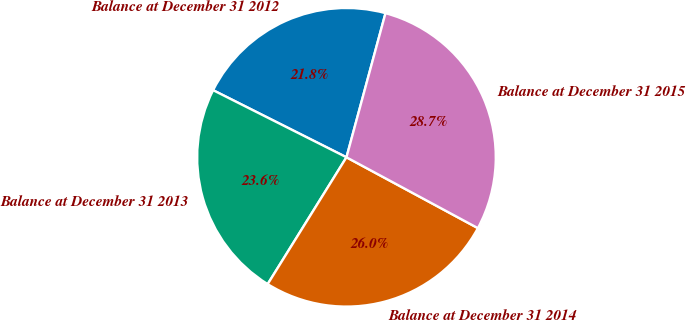Convert chart to OTSL. <chart><loc_0><loc_0><loc_500><loc_500><pie_chart><fcel>Balance at December 31 2012<fcel>Balance at December 31 2013<fcel>Balance at December 31 2014<fcel>Balance at December 31 2015<nl><fcel>21.79%<fcel>23.57%<fcel>25.98%<fcel>28.66%<nl></chart> 